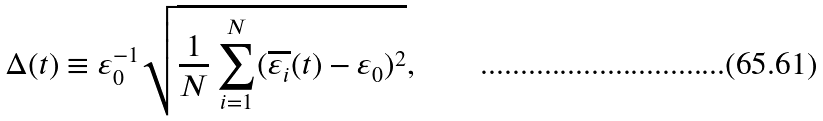<formula> <loc_0><loc_0><loc_500><loc_500>\Delta ( t ) \equiv \varepsilon _ { 0 } ^ { - 1 } \sqrt { \frac { 1 } { N } \sum _ { i = 1 } ^ { N } ( \overline { \varepsilon _ { i } } ( t ) - \varepsilon _ { 0 } ) ^ { 2 } } ,</formula> 